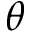<formula> <loc_0><loc_0><loc_500><loc_500>\theta</formula> 